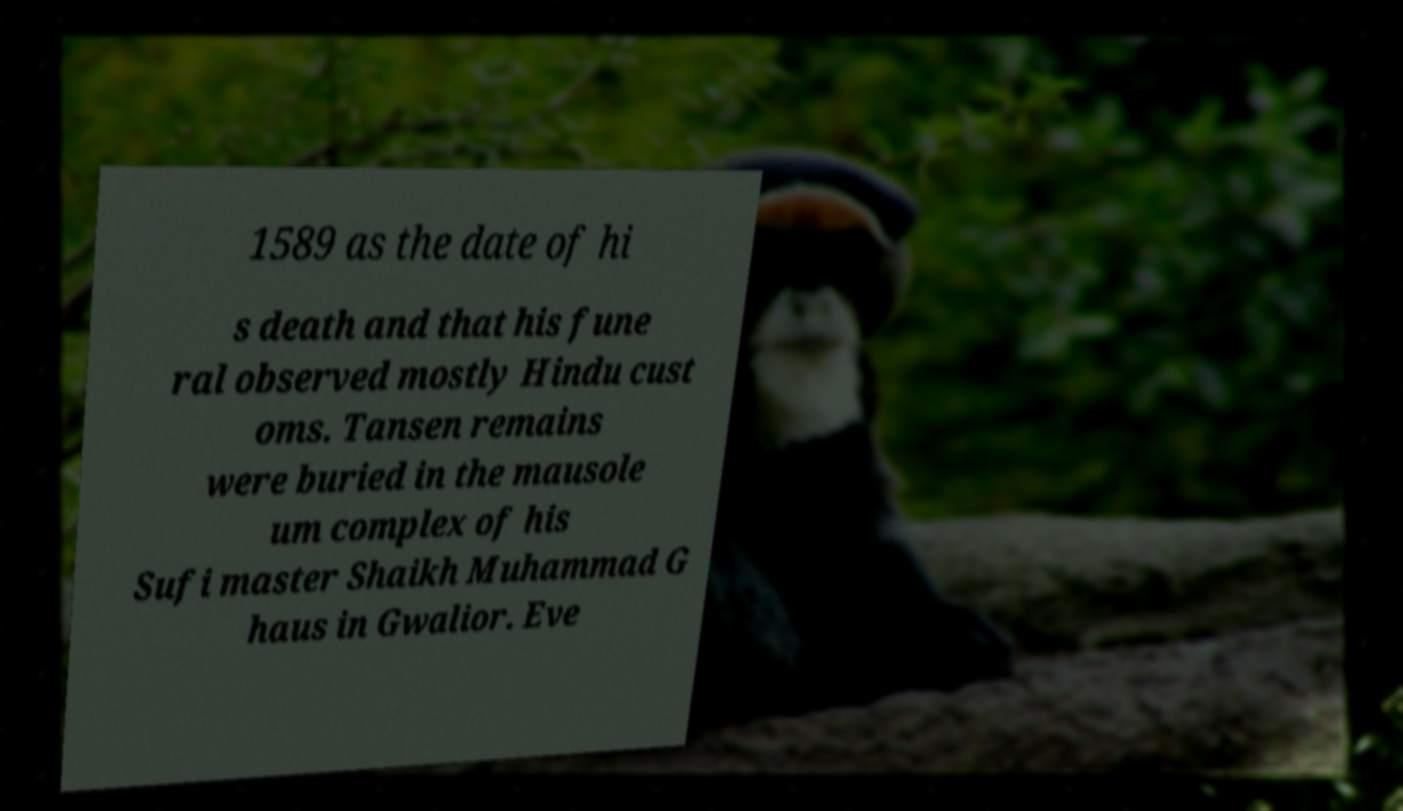For documentation purposes, I need the text within this image transcribed. Could you provide that? 1589 as the date of hi s death and that his fune ral observed mostly Hindu cust oms. Tansen remains were buried in the mausole um complex of his Sufi master Shaikh Muhammad G haus in Gwalior. Eve 